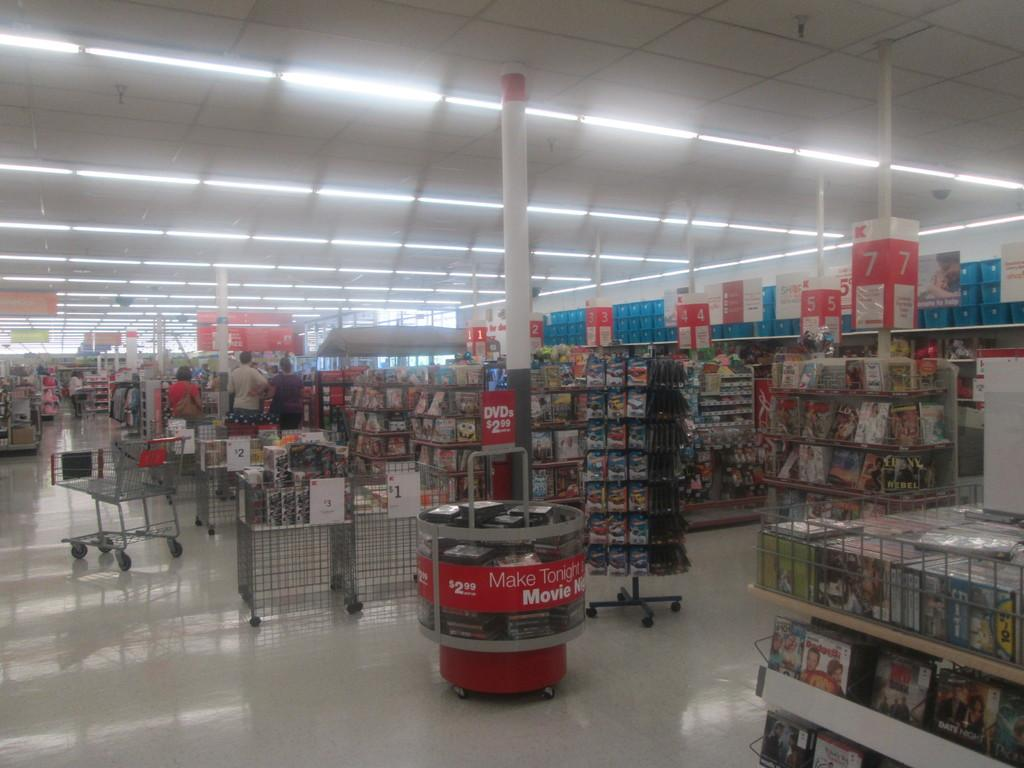<image>
Provide a brief description of the given image. the word movie is on the red and white sign 